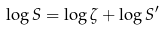Convert formula to latex. <formula><loc_0><loc_0><loc_500><loc_500>\log S = \log \zeta + \log S ^ { \prime }</formula> 